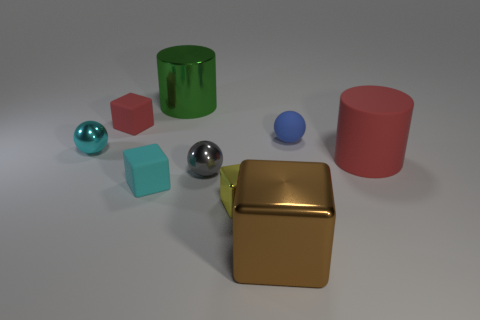What is the material of the small cube that is the same color as the large rubber cylinder?
Provide a short and direct response. Rubber. What number of metallic things are either small yellow balls or gray objects?
Ensure brevity in your answer.  1. Do the red rubber object behind the big red thing and the small cyan object on the left side of the tiny cyan rubber thing have the same shape?
Give a very brief answer. No. How many big metallic blocks are right of the gray metallic thing?
Make the answer very short. 1. Are there any brown things made of the same material as the tiny blue thing?
Make the answer very short. No. There is a cyan sphere that is the same size as the cyan rubber thing; what is it made of?
Provide a short and direct response. Metal. Is the material of the small yellow thing the same as the big red object?
Provide a succinct answer. No. How many things are red things or rubber cylinders?
Your answer should be compact. 2. The tiny shiny thing that is in front of the tiny gray sphere has what shape?
Your answer should be compact. Cube. What is the color of the big cylinder that is made of the same material as the blue ball?
Offer a very short reply. Red. 